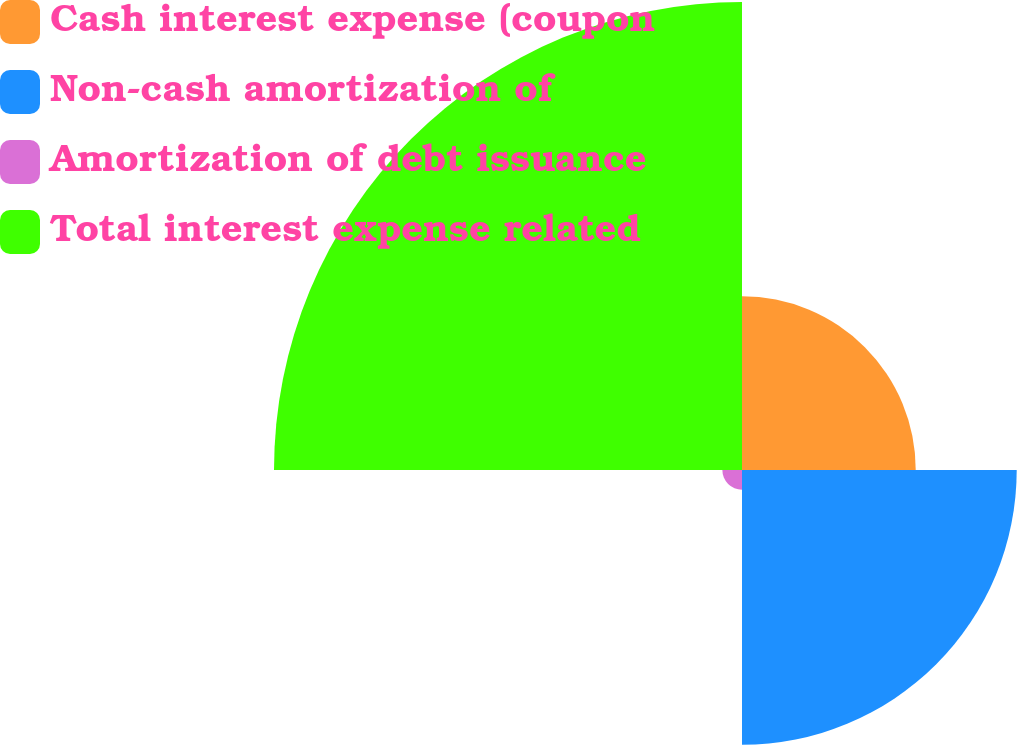<chart> <loc_0><loc_0><loc_500><loc_500><pie_chart><fcel>Cash interest expense (coupon<fcel>Non-cash amortization of<fcel>Amortization of debt issuance<fcel>Total interest expense related<nl><fcel>18.56%<fcel>29.35%<fcel>2.1%<fcel>50.0%<nl></chart> 